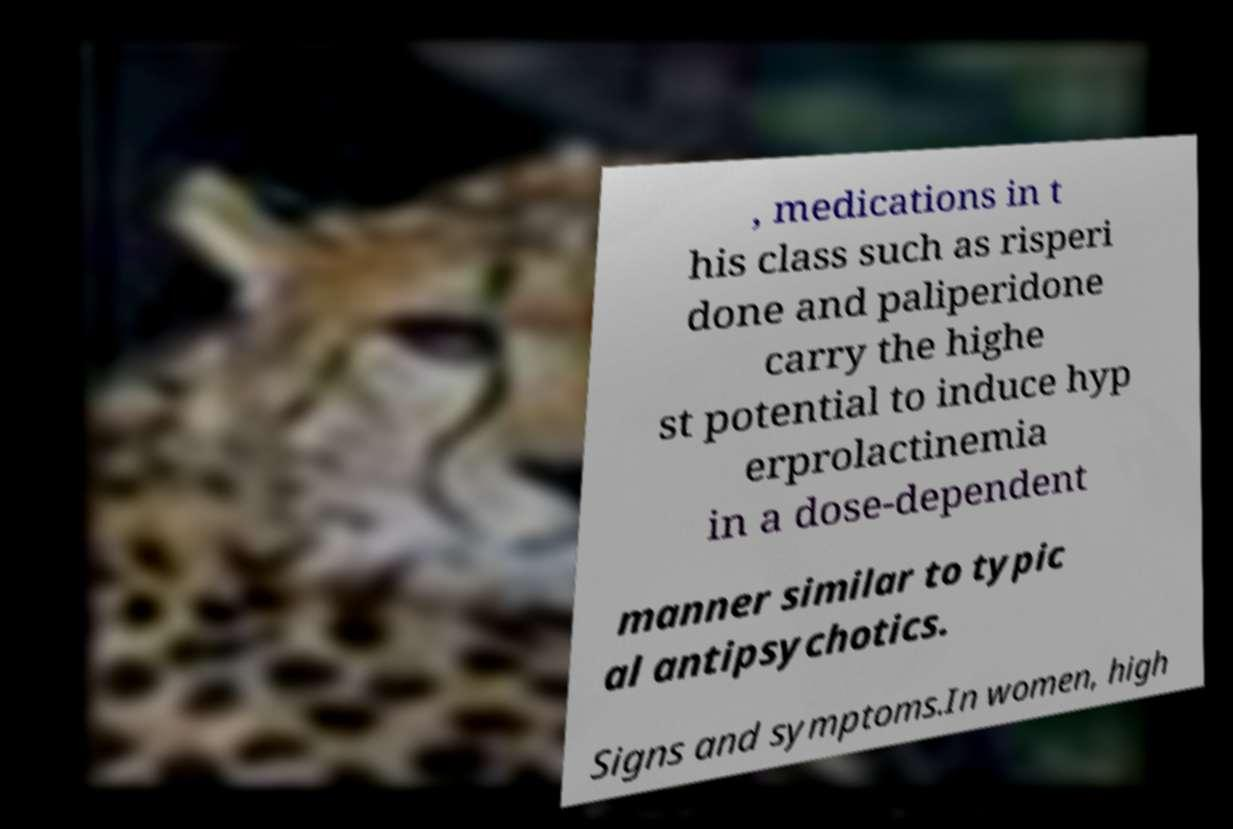Can you read and provide the text displayed in the image?This photo seems to have some interesting text. Can you extract and type it out for me? , medications in t his class such as risperi done and paliperidone carry the highe st potential to induce hyp erprolactinemia in a dose-dependent manner similar to typic al antipsychotics. Signs and symptoms.In women, high 